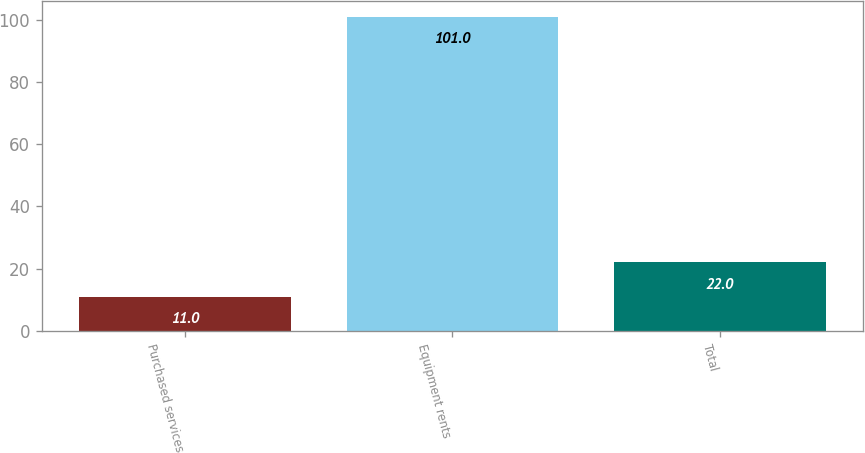<chart> <loc_0><loc_0><loc_500><loc_500><bar_chart><fcel>Purchased services<fcel>Equipment rents<fcel>Total<nl><fcel>11<fcel>101<fcel>22<nl></chart> 